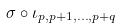Convert formula to latex. <formula><loc_0><loc_0><loc_500><loc_500>\sigma \circ \iota _ { p , p + 1 , \dots , p + q }</formula> 